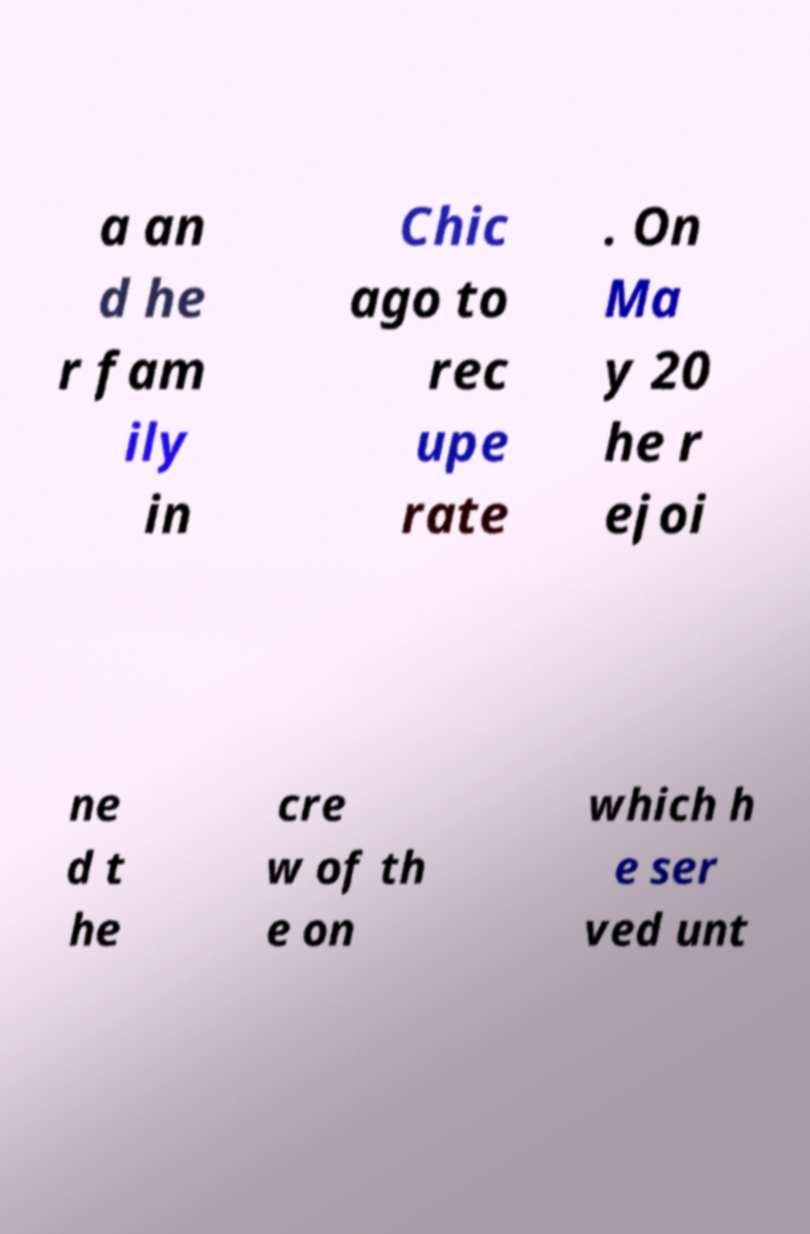For documentation purposes, I need the text within this image transcribed. Could you provide that? a an d he r fam ily in Chic ago to rec upe rate . On Ma y 20 he r ejoi ne d t he cre w of th e on which h e ser ved unt 